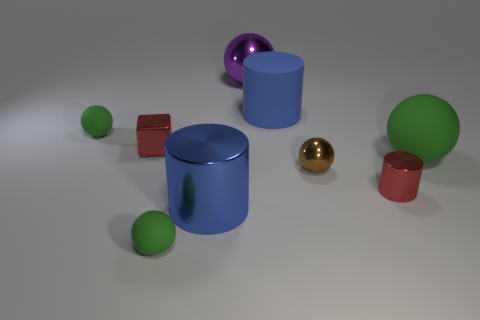What number of other things are there of the same color as the rubber cylinder?
Provide a short and direct response. 1. There is another blue object that is the same size as the blue rubber object; what shape is it?
Your response must be concise. Cylinder. The rubber object that is in front of the large rubber ball is what color?
Keep it short and to the point. Green. What number of things are big balls that are to the left of the brown metallic thing or shiny objects that are on the left side of the blue rubber thing?
Provide a short and direct response. 3. Do the brown thing and the red metal block have the same size?
Your response must be concise. Yes. What number of cylinders are big green metallic objects or tiny red objects?
Provide a succinct answer. 1. What number of rubber objects are left of the brown ball and to the right of the large purple thing?
Keep it short and to the point. 1. Does the purple thing have the same size as the blue object that is behind the tiny shiny ball?
Keep it short and to the point. Yes. There is a small red shiny object that is to the right of the large cylinder to the right of the big blue metal cylinder; are there any tiny red things to the right of it?
Make the answer very short. No. The cylinder behind the small ball behind the tiny brown metallic sphere is made of what material?
Provide a succinct answer. Rubber. 